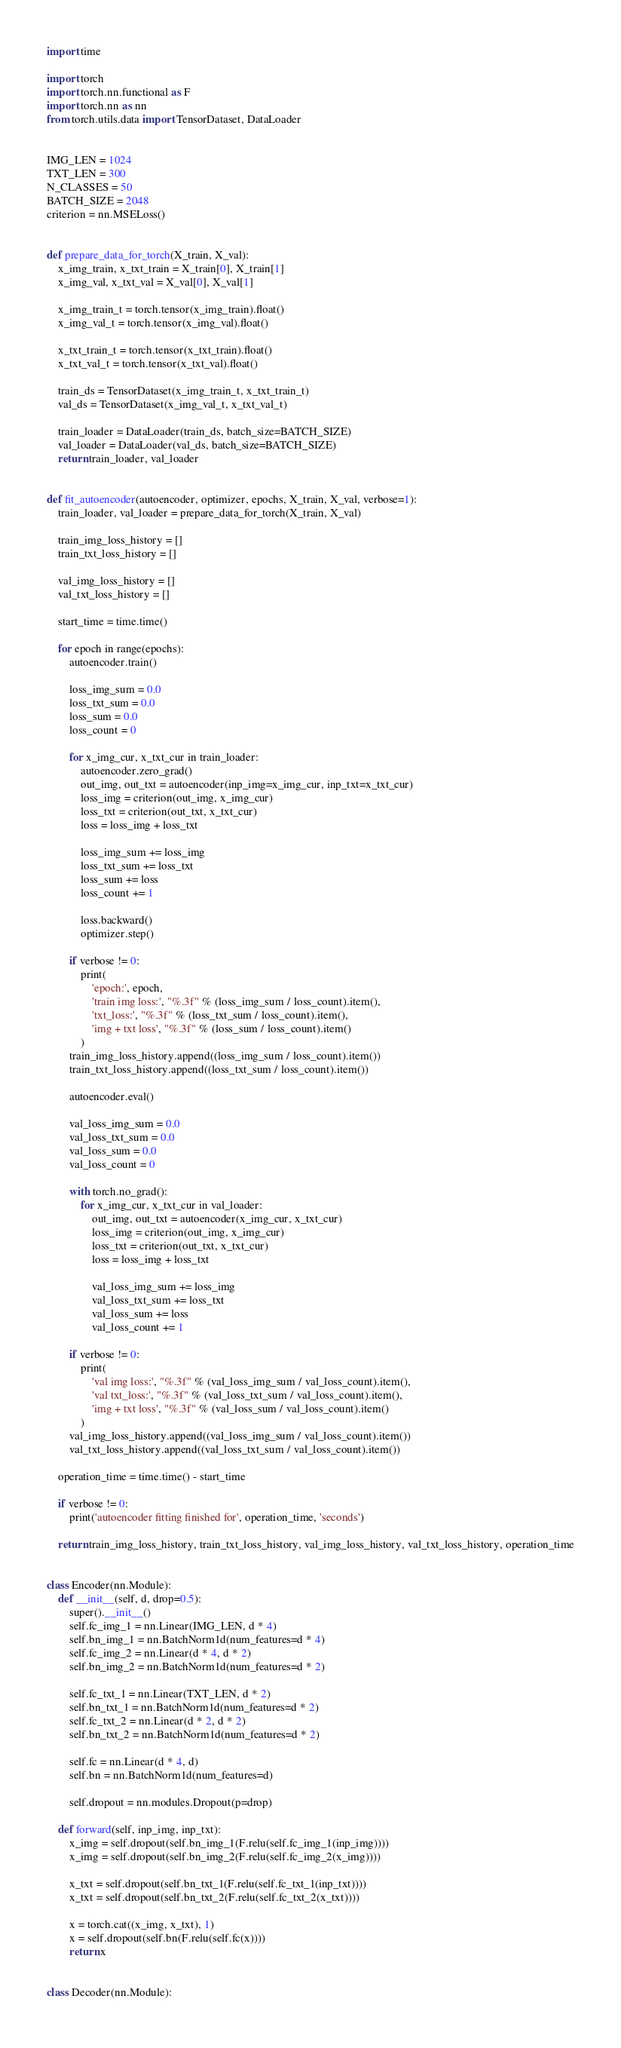<code> <loc_0><loc_0><loc_500><loc_500><_Python_>import time

import torch
import torch.nn.functional as F
import torch.nn as nn
from torch.utils.data import TensorDataset, DataLoader


IMG_LEN = 1024
TXT_LEN = 300
N_CLASSES = 50
BATCH_SIZE = 2048
criterion = nn.MSELoss()


def prepare_data_for_torch(X_train, X_val):
    x_img_train, x_txt_train = X_train[0], X_train[1]
    x_img_val, x_txt_val = X_val[0], X_val[1]

    x_img_train_t = torch.tensor(x_img_train).float()
    x_img_val_t = torch.tensor(x_img_val).float()

    x_txt_train_t = torch.tensor(x_txt_train).float()
    x_txt_val_t = torch.tensor(x_txt_val).float()

    train_ds = TensorDataset(x_img_train_t, x_txt_train_t)
    val_ds = TensorDataset(x_img_val_t, x_txt_val_t)

    train_loader = DataLoader(train_ds, batch_size=BATCH_SIZE)
    val_loader = DataLoader(val_ds, batch_size=BATCH_SIZE)
    return train_loader, val_loader


def fit_autoencoder(autoencoder, optimizer, epochs, X_train, X_val, verbose=1):
    train_loader, val_loader = prepare_data_for_torch(X_train, X_val)

    train_img_loss_history = []
    train_txt_loss_history = []

    val_img_loss_history = []
    val_txt_loss_history = []

    start_time = time.time()

    for epoch in range(epochs):
        autoencoder.train()

        loss_img_sum = 0.0
        loss_txt_sum = 0.0
        loss_sum = 0.0
        loss_count = 0

        for x_img_cur, x_txt_cur in train_loader:
            autoencoder.zero_grad()
            out_img, out_txt = autoencoder(inp_img=x_img_cur, inp_txt=x_txt_cur)
            loss_img = criterion(out_img, x_img_cur)
            loss_txt = criterion(out_txt, x_txt_cur)
            loss = loss_img + loss_txt

            loss_img_sum += loss_img
            loss_txt_sum += loss_txt
            loss_sum += loss
            loss_count += 1

            loss.backward()
            optimizer.step()

        if verbose != 0:
            print(
                'epoch:', epoch,
                'train img loss:', "%.3f" % (loss_img_sum / loss_count).item(),
                'txt_loss:', "%.3f" % (loss_txt_sum / loss_count).item(),
                'img + txt loss', "%.3f" % (loss_sum / loss_count).item()
            )
        train_img_loss_history.append((loss_img_sum / loss_count).item())
        train_txt_loss_history.append((loss_txt_sum / loss_count).item())

        autoencoder.eval()

        val_loss_img_sum = 0.0
        val_loss_txt_sum = 0.0
        val_loss_sum = 0.0
        val_loss_count = 0

        with torch.no_grad():
            for x_img_cur, x_txt_cur in val_loader:
                out_img, out_txt = autoencoder(x_img_cur, x_txt_cur)
                loss_img = criterion(out_img, x_img_cur)
                loss_txt = criterion(out_txt, x_txt_cur)
                loss = loss_img + loss_txt

                val_loss_img_sum += loss_img
                val_loss_txt_sum += loss_txt
                val_loss_sum += loss
                val_loss_count += 1

        if verbose != 0:
            print(
                'val img loss:', "%.3f" % (val_loss_img_sum / val_loss_count).item(),
                'val txt_loss:', "%.3f" % (val_loss_txt_sum / val_loss_count).item(),
                'img + txt loss', "%.3f" % (val_loss_sum / val_loss_count).item()
            )
        val_img_loss_history.append((val_loss_img_sum / val_loss_count).item())
        val_txt_loss_history.append((val_loss_txt_sum / val_loss_count).item())

    operation_time = time.time() - start_time

    if verbose != 0:
        print('autoencoder fitting finished for', operation_time, 'seconds')

    return train_img_loss_history, train_txt_loss_history, val_img_loss_history, val_txt_loss_history, operation_time


class Encoder(nn.Module):
    def __init__(self, d, drop=0.5):
        super().__init__()
        self.fc_img_1 = nn.Linear(IMG_LEN, d * 4)
        self.bn_img_1 = nn.BatchNorm1d(num_features=d * 4)
        self.fc_img_2 = nn.Linear(d * 4, d * 2)
        self.bn_img_2 = nn.BatchNorm1d(num_features=d * 2)

        self.fc_txt_1 = nn.Linear(TXT_LEN, d * 2)
        self.bn_txt_1 = nn.BatchNorm1d(num_features=d * 2)
        self.fc_txt_2 = nn.Linear(d * 2, d * 2)
        self.bn_txt_2 = nn.BatchNorm1d(num_features=d * 2)

        self.fc = nn.Linear(d * 4, d)
        self.bn = nn.BatchNorm1d(num_features=d)

        self.dropout = nn.modules.Dropout(p=drop)

    def forward(self, inp_img, inp_txt):
        x_img = self.dropout(self.bn_img_1(F.relu(self.fc_img_1(inp_img))))
        x_img = self.dropout(self.bn_img_2(F.relu(self.fc_img_2(x_img))))

        x_txt = self.dropout(self.bn_txt_1(F.relu(self.fc_txt_1(inp_txt))))
        x_txt = self.dropout(self.bn_txt_2(F.relu(self.fc_txt_2(x_txt))))

        x = torch.cat((x_img, x_txt), 1)
        x = self.dropout(self.bn(F.relu(self.fc(x))))
        return x


class Decoder(nn.Module):</code> 